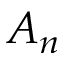<formula> <loc_0><loc_0><loc_500><loc_500>A _ { n }</formula> 